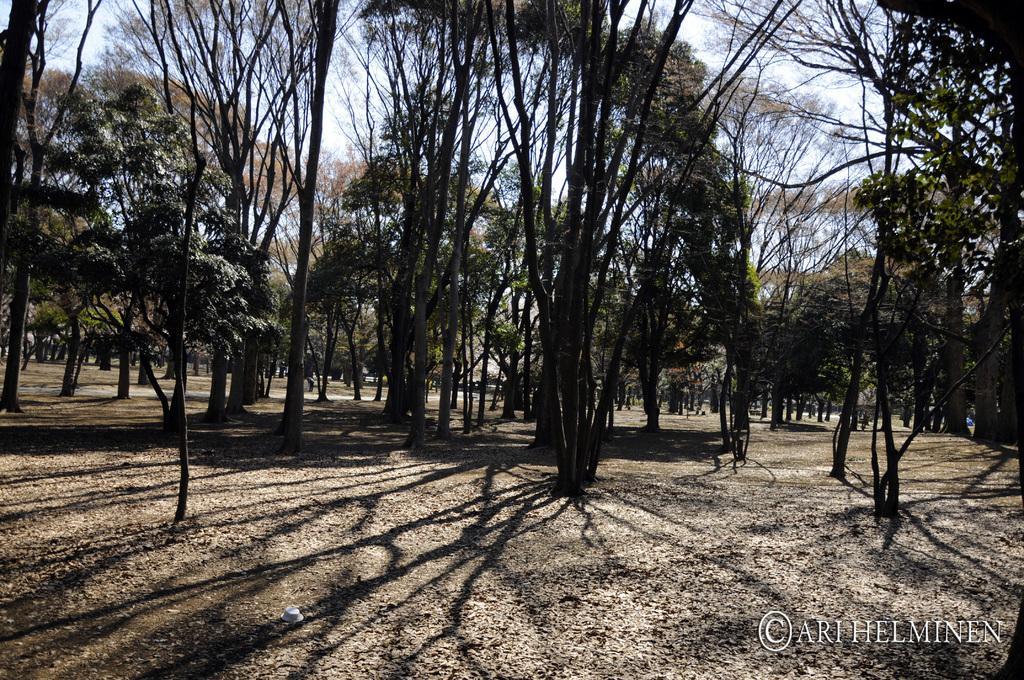Could you give a brief overview of what you see in this image? In this picture there are trees. At the top there is sky. At the bottom there is ground and there are dried leaves. At the bottom right there is text. 